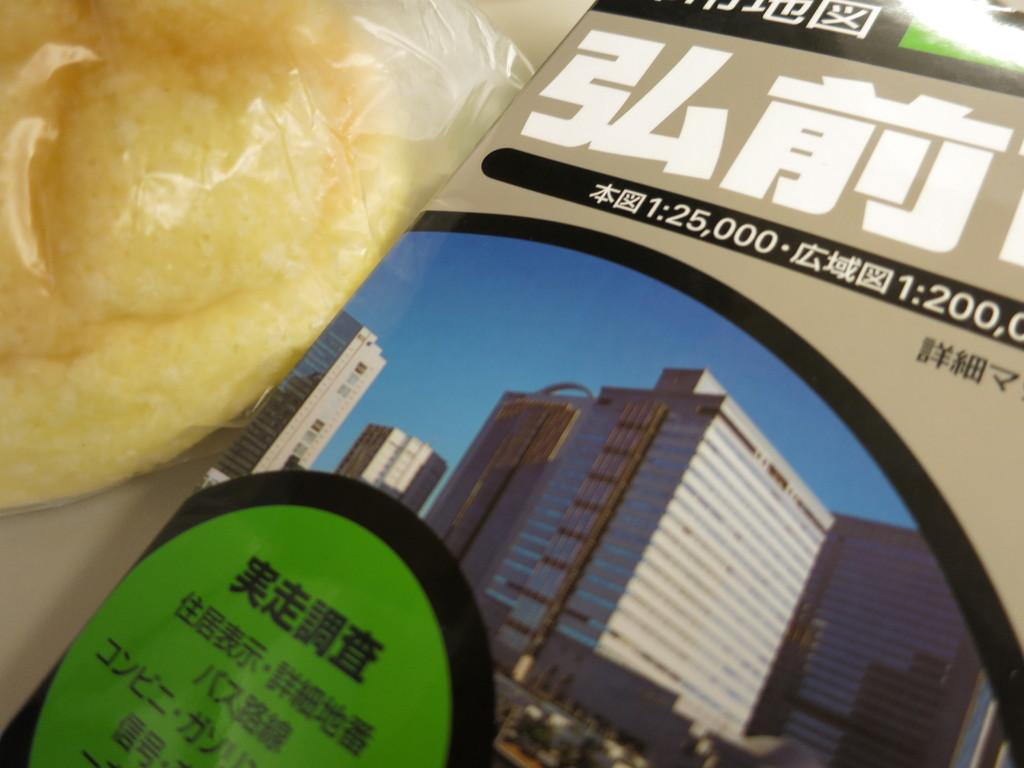What type of reading material is present in the image? There is a magazine in the image. What else can be seen in the image besides the magazine? There is a food item in the image. What type of reaction can be seen happening to the magazine in the image? There is no reaction happening to the magazine in the image; it is a static object. Is there a fire present in the image? No, there is no fire present in the image. Can you spot a rat in the image? No, there is no rat present in the image. 